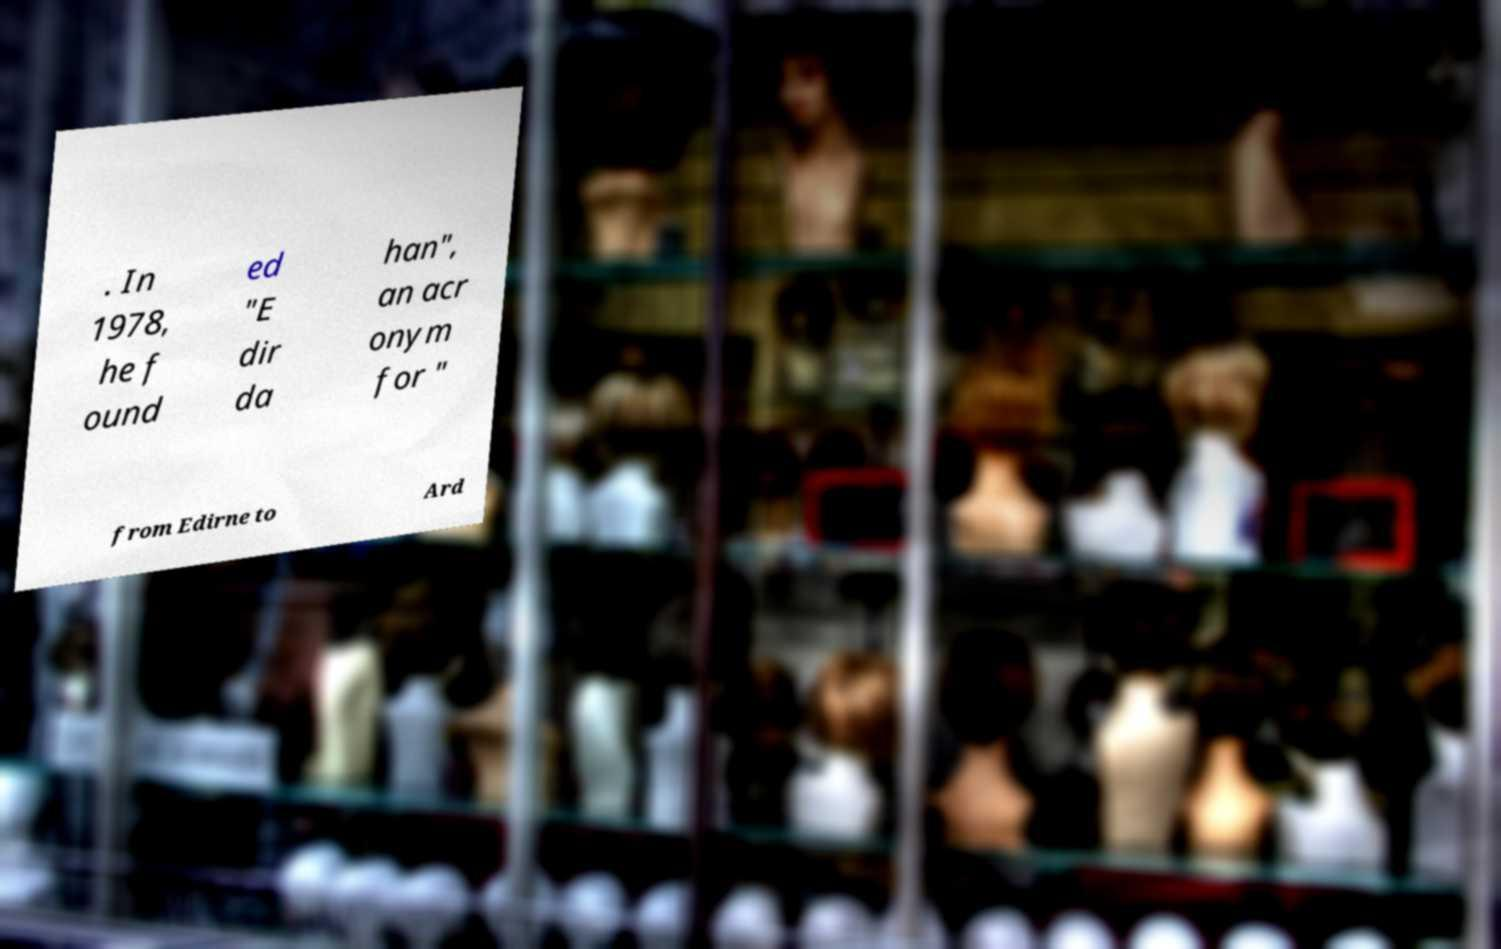What messages or text are displayed in this image? I need them in a readable, typed format. . In 1978, he f ound ed "E dir da han", an acr onym for " from Edirne to Ard 